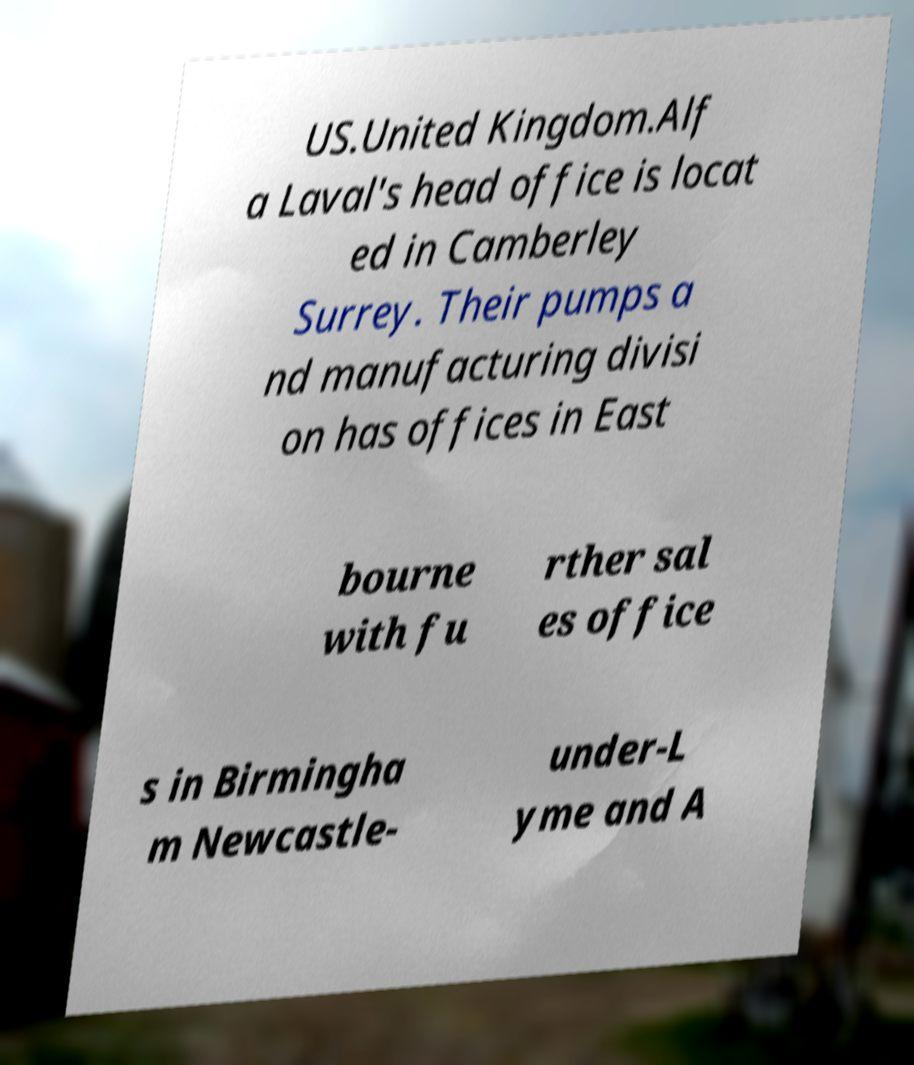Can you accurately transcribe the text from the provided image for me? US.United Kingdom.Alf a Laval's head office is locat ed in Camberley Surrey. Their pumps a nd manufacturing divisi on has offices in East bourne with fu rther sal es office s in Birmingha m Newcastle- under-L yme and A 